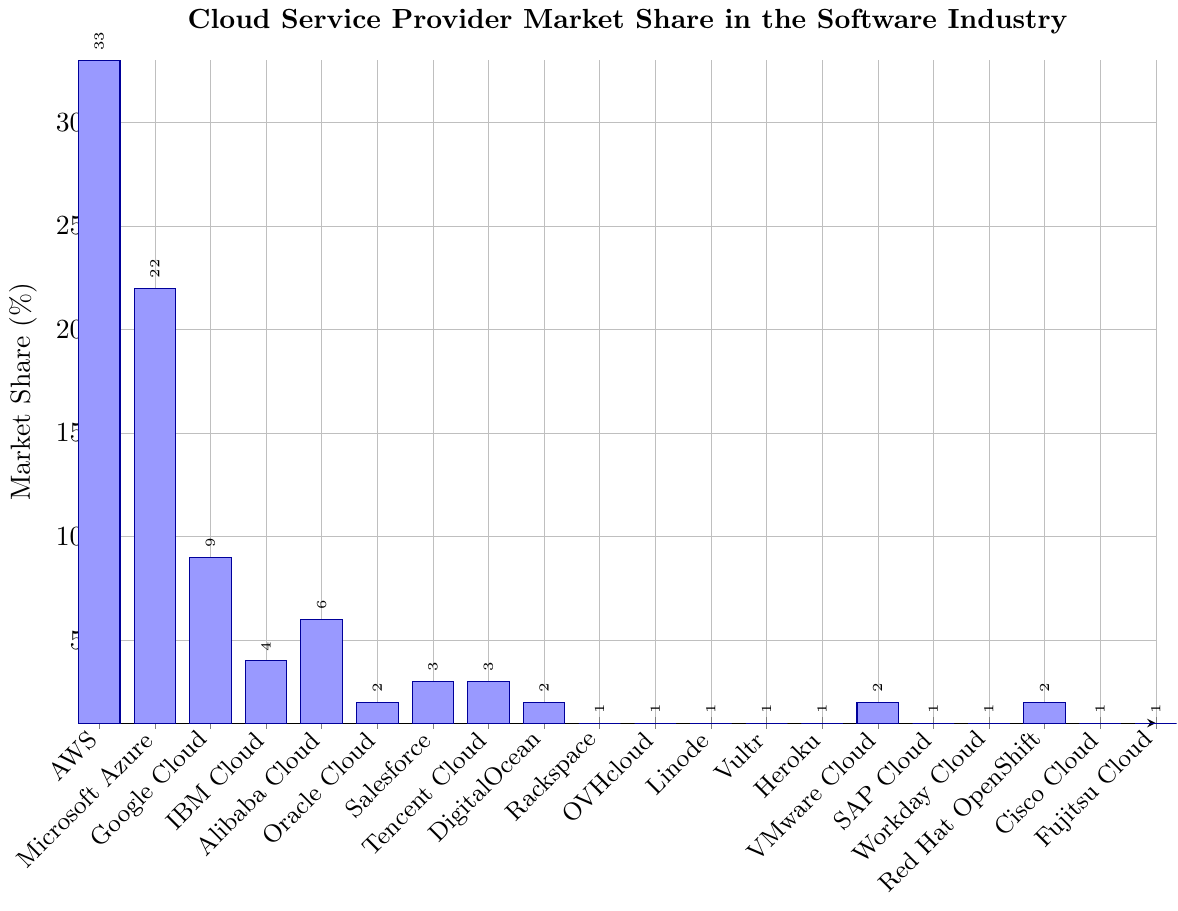What's the market share of the top three cloud providers combined? To find the combined market share of AWS, Microsoft Azure, and Google Cloud, add their individual market shares: 33% (AWS) + 22% (Microsoft Azure) + 9% (Google Cloud) = 64%
Answer: 64% Which cloud provider has the lowest market share? Find the bar with the smallest height. The providers with the lowest share (1%) are Rackspace, OVHcloud, Linode, Vultr, Heroku, SAP Cloud, Workday Cloud, Cisco Cloud, and Fujitsu Cloud. Pick any one of them.
Answer: Rackspace (also several others with 1%) How much more market share does AWS have compared to Google Cloud? Subtract Google Cloud’s market share from AWS’s: 33% (AWS) - 9% (Google Cloud) = 24%
Answer: 24% What percentage of the total market is held by IBM Cloud and Oracle Cloud together? Add their market shares: 4% (IBM Cloud) + 2% (Oracle Cloud) = 6%
Answer: 6% Rank the top five cloud providers by market share. Observe the heights of the bars and rank from highest to lowest: AWS (33%), Microsoft Azure (22%), Google Cloud (9%), Alibaba Cloud (6%), IBM Cloud (4%)
Answer: AWS, Microsoft Azure, Google Cloud, Alibaba Cloud, IBM Cloud What is the difference in market share between the largest and the smallest providers? Subtract the smallest share (1%) from the largest share (33%): 33% - 1% = 32%
Answer: 32% What is the average market share of Oracle Cloud, Salesforce, and Red Hat OpenShift? Add their market shares and divide by the number of providers: (2% + 3% + 2%) / 3 = 7% / 3 ≈ 2.33%
Answer: 2.33% Which providers have exactly 2% market share? Identify the bars labeled with 2%: Oracle Cloud, DigitalOcean, VMware Cloud, Red Hat OpenShift
Answer: Oracle Cloud, DigitalOcean, VMware Cloud, Red Hat OpenShift How much more market share does Microsoft Azure have compared to the combined share of Salesforce and Tencent Cloud? Add Salesforce and Tencent Cloud shares first: 3% + 3% = 6%, then subtract this sum from Microsoft Azure's share: 22% (Microsoft Azure) - 6% = 16%
Answer: 16% What is the combined market share of all providers showing 1%? Count and add the market share of all providers with 1%: Rackspace, OVHcloud, Linode, Vultr, Heroku, SAP Cloud, Workday Cloud, Cisco Cloud, Fujitsu Cloud: 1% * 9 = 9%
Answer: 9% 